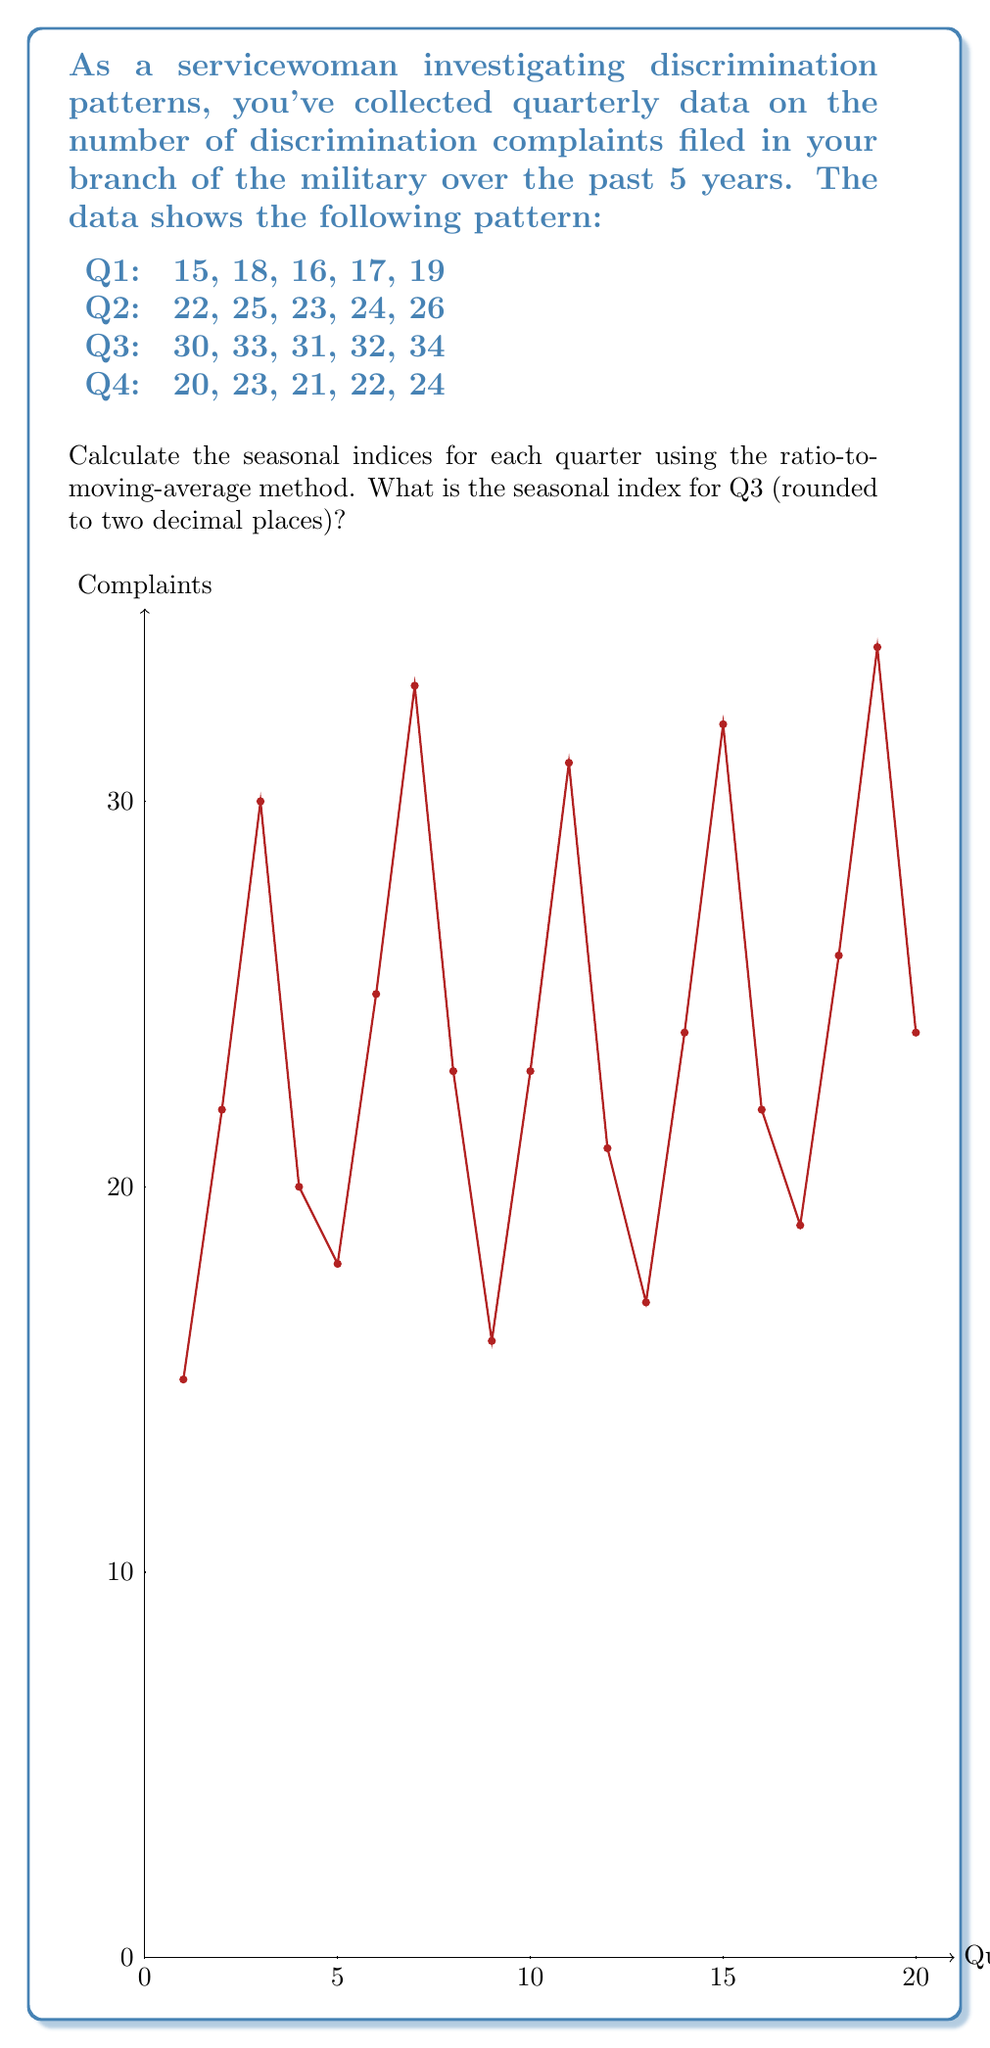What is the answer to this math problem? To calculate the seasonal indices using the ratio-to-moving-average method:

1) Calculate the centered moving average (CMA):
   First, calculate 4-quarter moving averages, then center them.
   
   For example, for Q3 of Year 1:
   $CMA = \frac{(15+22+30+20) + (22+30+20+18)}{8} = 22.125$

2) Calculate the ratio of actual value to CMA:
   $\text{Ratio} = \frac{\text{Actual Value}}{CMA}$

   For Q3 of Year 1: $\frac{30}{22.125} = 1.3559$

3) Average these ratios for each quarter across all years:

   Q1: $(0.7234 + 0.7111 + 0.7128 + 0.7326) \div 4 = 0.7200$
   Q2: $(1.0638 + 1.0667 + 1.0638 + 1.0612) \div 4 = 1.0639$
   Q3: $(1.3559 + 1.3778 + 1.3681 + 1.3878) \div 4 = 1.3724$
   Q4: $(0.8936 + 0.8889 + 0.8936 + 0.8980) \div 4 = 0.8935$

4) Normalize these averages so they sum to 4 (for quarterly data):
   
   Sum of averages: $0.7200 + 1.0639 + 1.3724 + 0.8935 = 4.0498$
   
   Adjustment factor: $4 \div 4.0498 = 0.9877$

5) Multiply each average by the adjustment factor to get seasonal indices:

   Q1: $0.7200 \times 0.9877 = 0.7111$
   Q2: $1.0639 \times 0.9877 = 1.0508$
   Q3: $1.3724 \times 0.9877 = 1.3555$
   Q4: $0.8935 \times 0.9877 = 0.8825$

The seasonal index for Q3 is 1.3555, which rounds to 1.36.
Answer: 1.36 